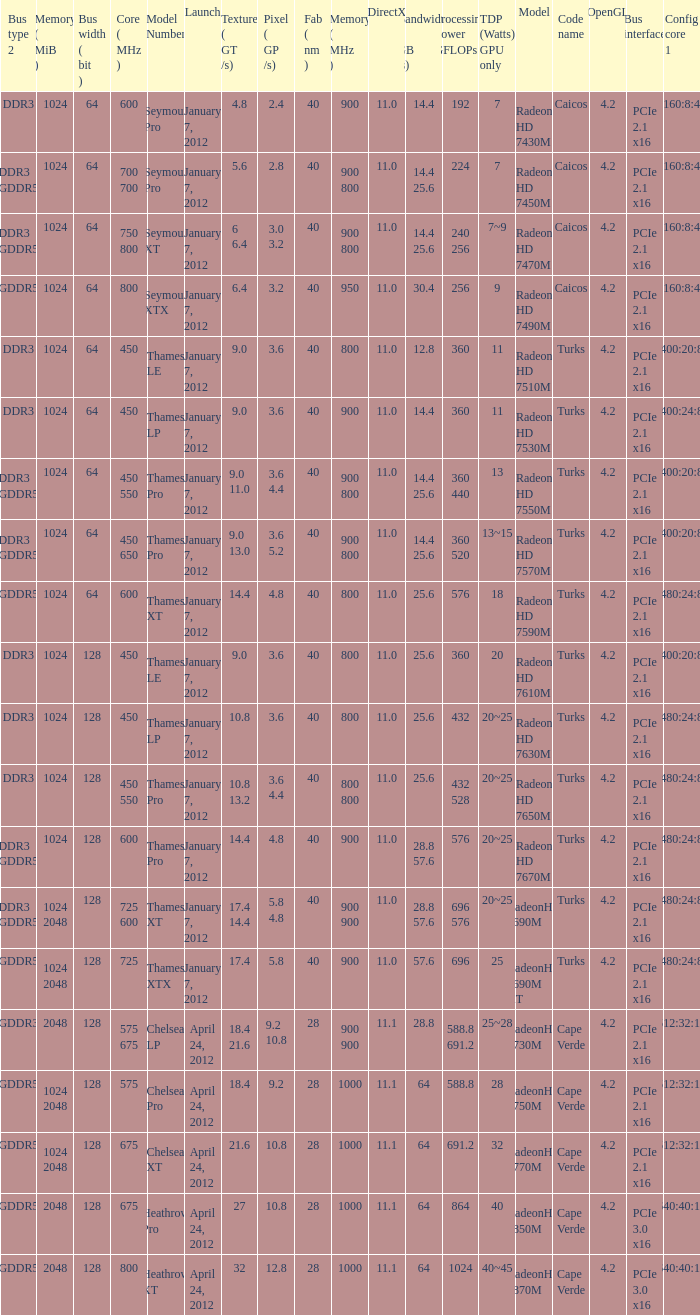What was the maximum fab (nm)? 40.0. 